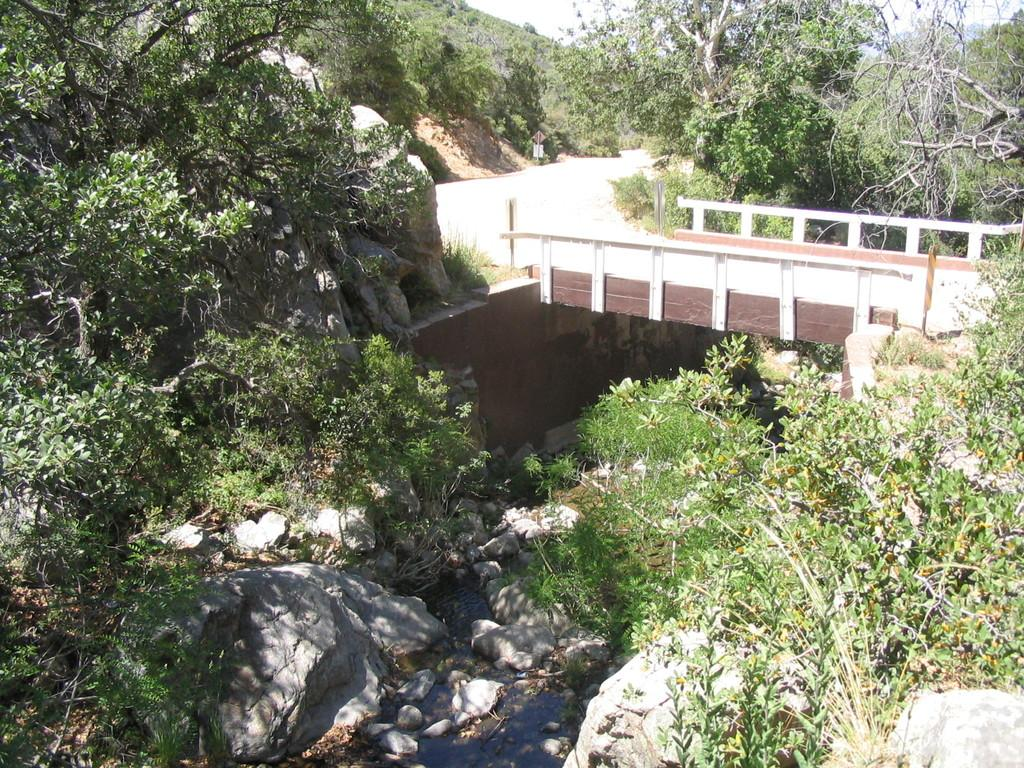What type of natural elements can be seen in the image? There are rocks and trees in the image. What man-made structure is present in the image? There is a bridge in the center of the image. How many giants are standing on the bridge in the image? There are no giants present in the image; it features rocks, trees, and a bridge. What type of furniture can be seen on the rocks in the image? There is no furniture, such as a desk, present in the image; it only contains rocks, trees, and a bridge. 